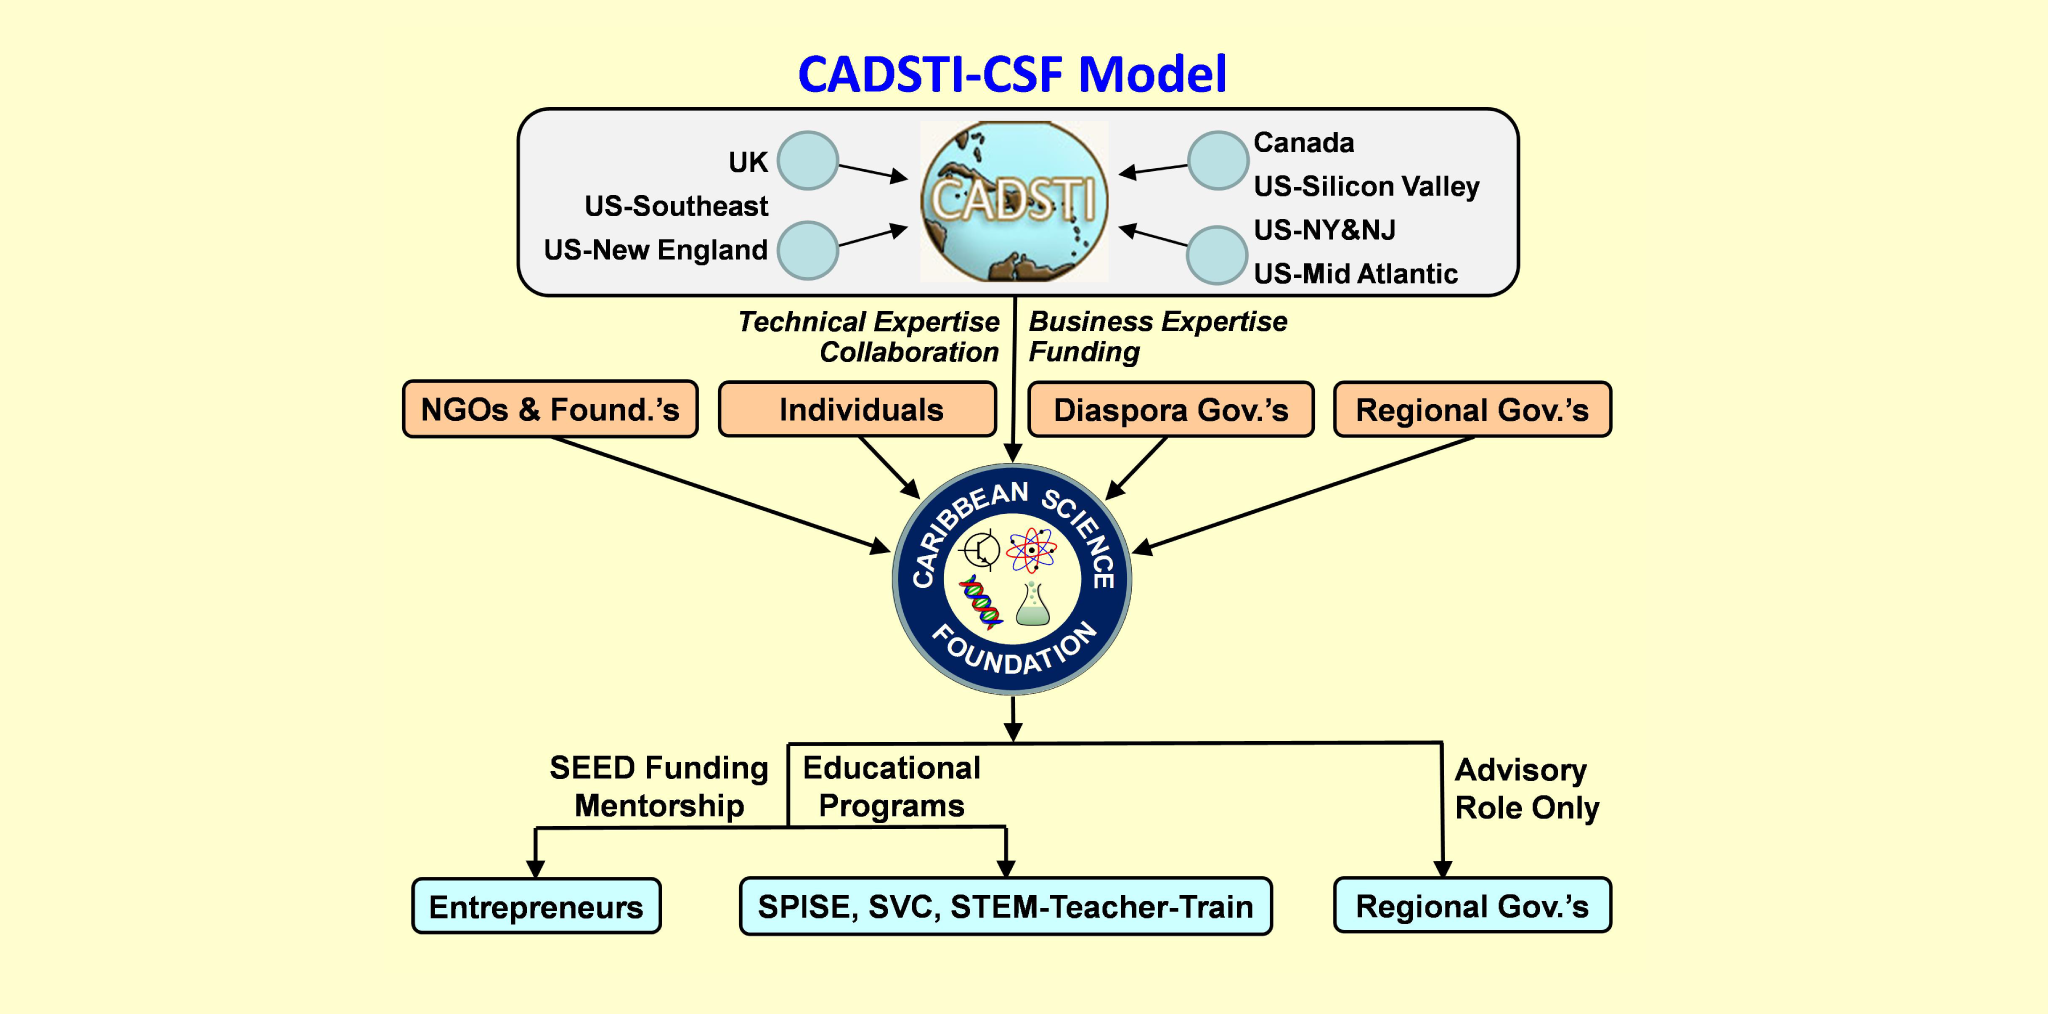Considering the listed geographic collaborations, what unique challenges might the Caribbean Science Foundation face, and how could it potentially overcome them? The Caribbean Science Foundation might face several challenges, including logistical difficulties in coordinating across multiple time zones and regions, cultural differences that affect collaboration styles, and potential funding constraints. To overcome these challenges, the foundation could establish a robust digital communication infrastructure to facilitate real-time collaboration. Additionally, it could implement cultural competency training for all partners to ensure effective and respectful communication. Diversifying its funding sources and creating a sustainable financial model would also be essential in mitigating funding-related challenges. 